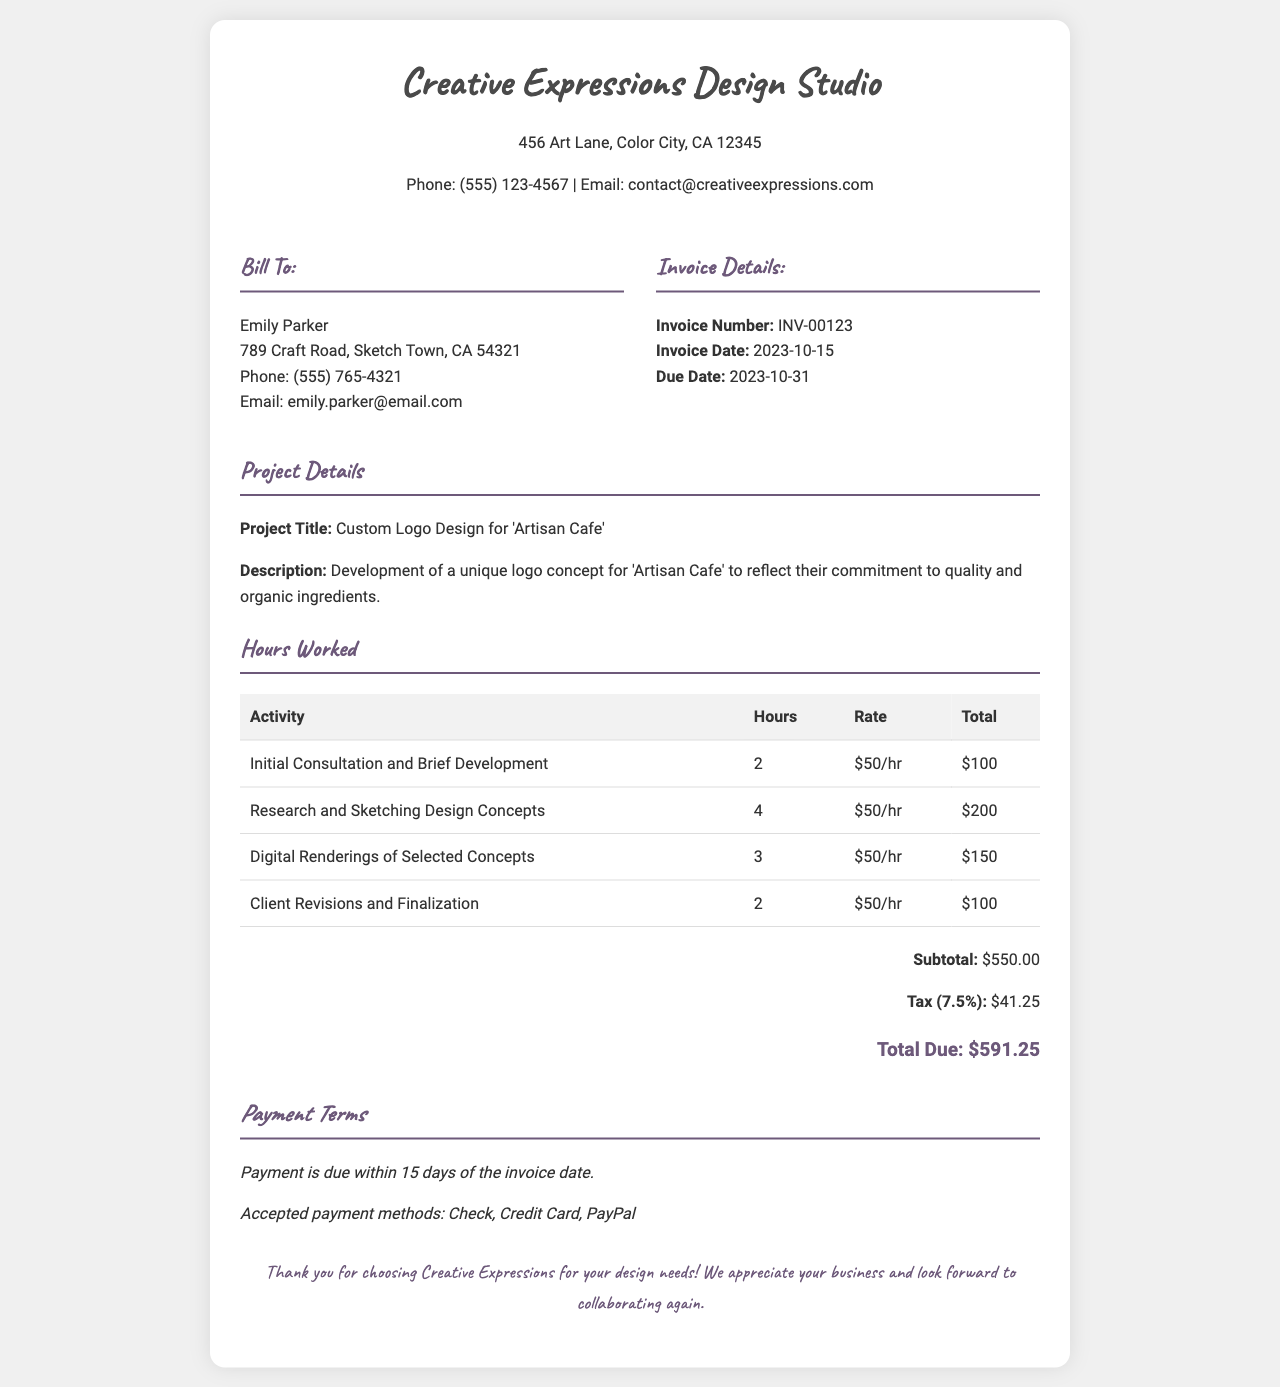What is the invoice number? The invoice number is a unique identifier for the invoice, found in the invoice details section.
Answer: INV-00123 What is the total due amount? The total due amount is the final sum after adding the subtotal and tax, displayed at the bottom of the invoice.
Answer: $591.25 Who is the client for this invoice? The client's name is listed at the beginning of the bill to section.
Answer: Emily Parker What is the tax rate applied to the invoice? The tax rate is mentioned in the summary section of the invoice.
Answer: 7.5% How many total hours were worked on the project? The total hours can be found by adding the hours from all activities listed in the hours worked section.
Answer: 11 What is the due date for the payment? The due date is given in the invoice details section, indicating when the payment should be made.
Answer: 2023-10-31 What type of project is this invoice for? The project type is found in the project details section, indicating the nature of the work done.
Answer: Custom Logo Design How many activities are listed in the hours worked section? The number of activities can be counted from the rows in the hours worked table.
Answer: 4 What is the description of the project? The project description provides insight into what the work entails, found in the project details section.
Answer: Development of a unique logo concept for 'Artisan Cafe' to reflect their commitment to quality and organic ingredients 